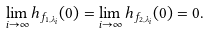Convert formula to latex. <formula><loc_0><loc_0><loc_500><loc_500>\lim _ { i \to \infty } h _ { f _ { 1 , \lambda _ { i } } } ( 0 ) = \lim _ { i \to \infty } h _ { f _ { 2 , \lambda _ { i } } } ( 0 ) = 0 .</formula> 